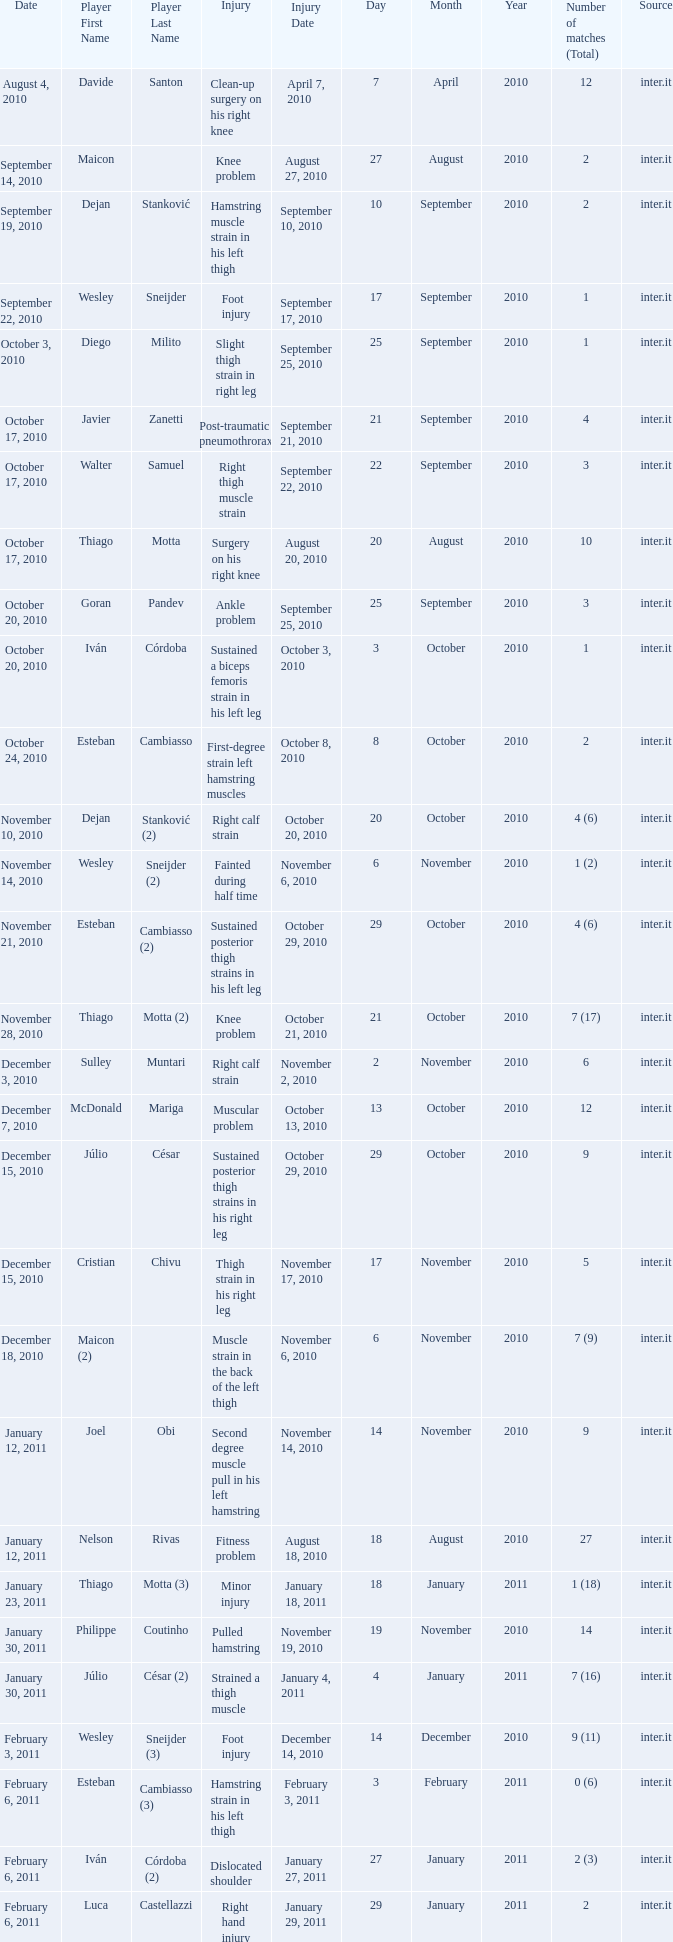What is the date of injury when the injury is foot injury and the number of matches (total) is 1? September 17, 2010. 